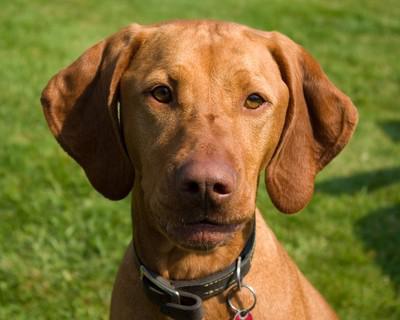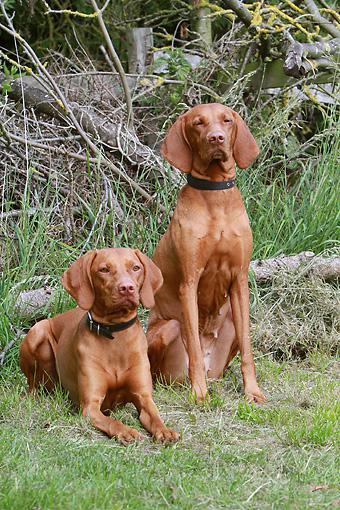The first image is the image on the left, the second image is the image on the right. Assess this claim about the two images: "A total of three red-orange dogs, all wearing collars, are shown - and the right image contains two side-by-side dogs gazing in the same direction.". Correct or not? Answer yes or no. Yes. The first image is the image on the left, the second image is the image on the right. For the images displayed, is the sentence "One dog's teeth are visible." factually correct? Answer yes or no. No. 